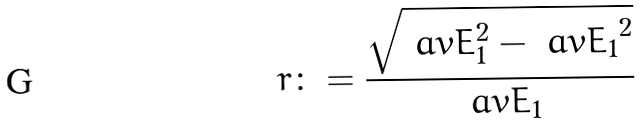<formula> <loc_0><loc_0><loc_500><loc_500>r \colon = \frac { \sqrt { \ a v { E _ { 1 } ^ { 2 } } - \ a v { E _ { 1 } } ^ { 2 } } } { \ a v { E _ { 1 } } }</formula> 